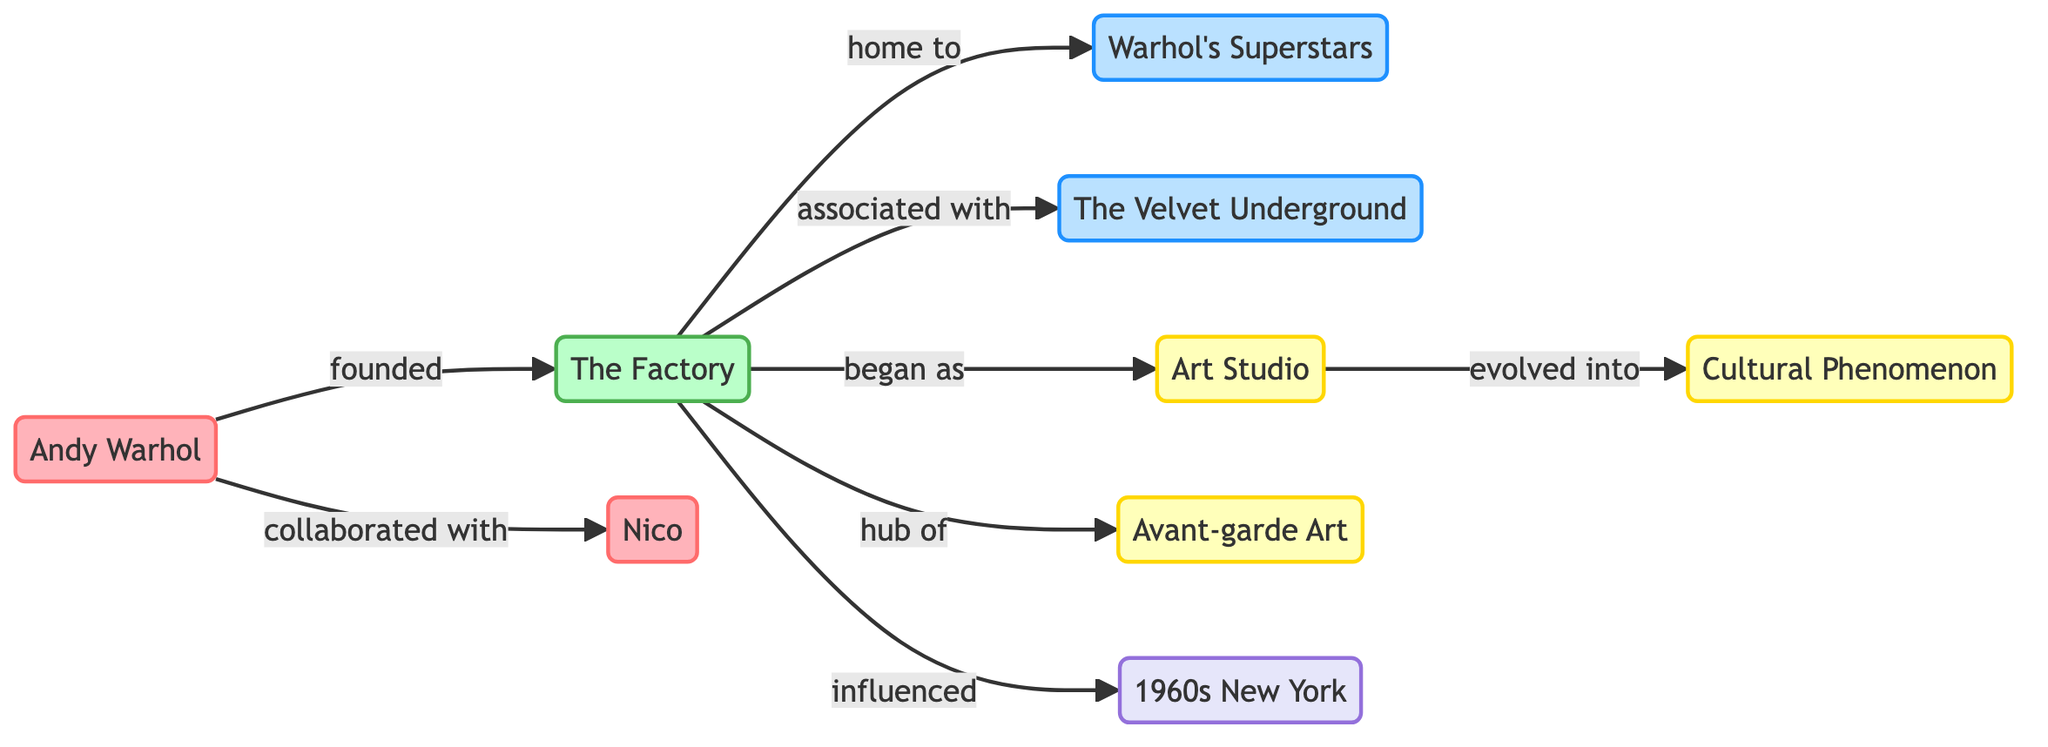What is the main person associated with The Factory? The diagram indicates that Andy Warhol is the primary individual linked to The Factory, as he is the one who founded it.
Answer: Andy Warhol How many groups are represented in the diagram? By examining the nodes, we see two distinct groups: Warhol's Superstars and The Velvet Underground. Thus, the total is two.
Answer: 2 What did The Factory begin as? The edge labeled "began as" connecting The Factory to Art Studio shows that it initially started as an Art Studio.
Answer: Art Studio Who collaborated with Andy Warhol? The connection labeled "collaborated with" between Andy Warhol and Nico indicates that Nico is the one who worked with him.
Answer: Nico What cultural impact did The Factory have in 1960s New York? The relationship labeled "influenced" shows that The Factory had a significant impact on the cultural landscape of 1960s New York.
Answer: influenced In what way did the Art Studio evolve? The edge marked "evolved into" denotes that the Art Studio transformed into a Cultural Phenomenon, indicating a change from a specific identity to a broader cultural significance.
Answer: Cultural Phenomenon Which concept is The Factory a hub of? The edge shows that The Factory is labeled as a hub of Avant-garde Art, signifying its role in the avant-garde artistic movement.
Answer: Avant-garde Art What is the relationship between The Factory and the Superstars? The label "home to" indicates that The Factory served as the place where Warhol's Superstars gathered and thrived, emphasizing a strong connection between the two.
Answer: home to What connects Nico to the cultural landscape represented in the map? The collaboration with Andy Warhol positions Nico within the creative scene surrounding The Factory, linking her to the emerging cultural developments represented in the diagram.
Answer: collaborated with 